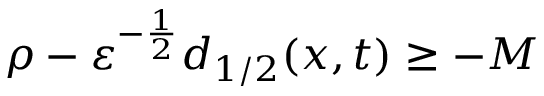<formula> <loc_0><loc_0><loc_500><loc_500>\rho - { \varepsilon } ^ { - \frac { 1 } { 2 } } d _ { 1 / 2 } ( x , t ) \geq - M</formula> 